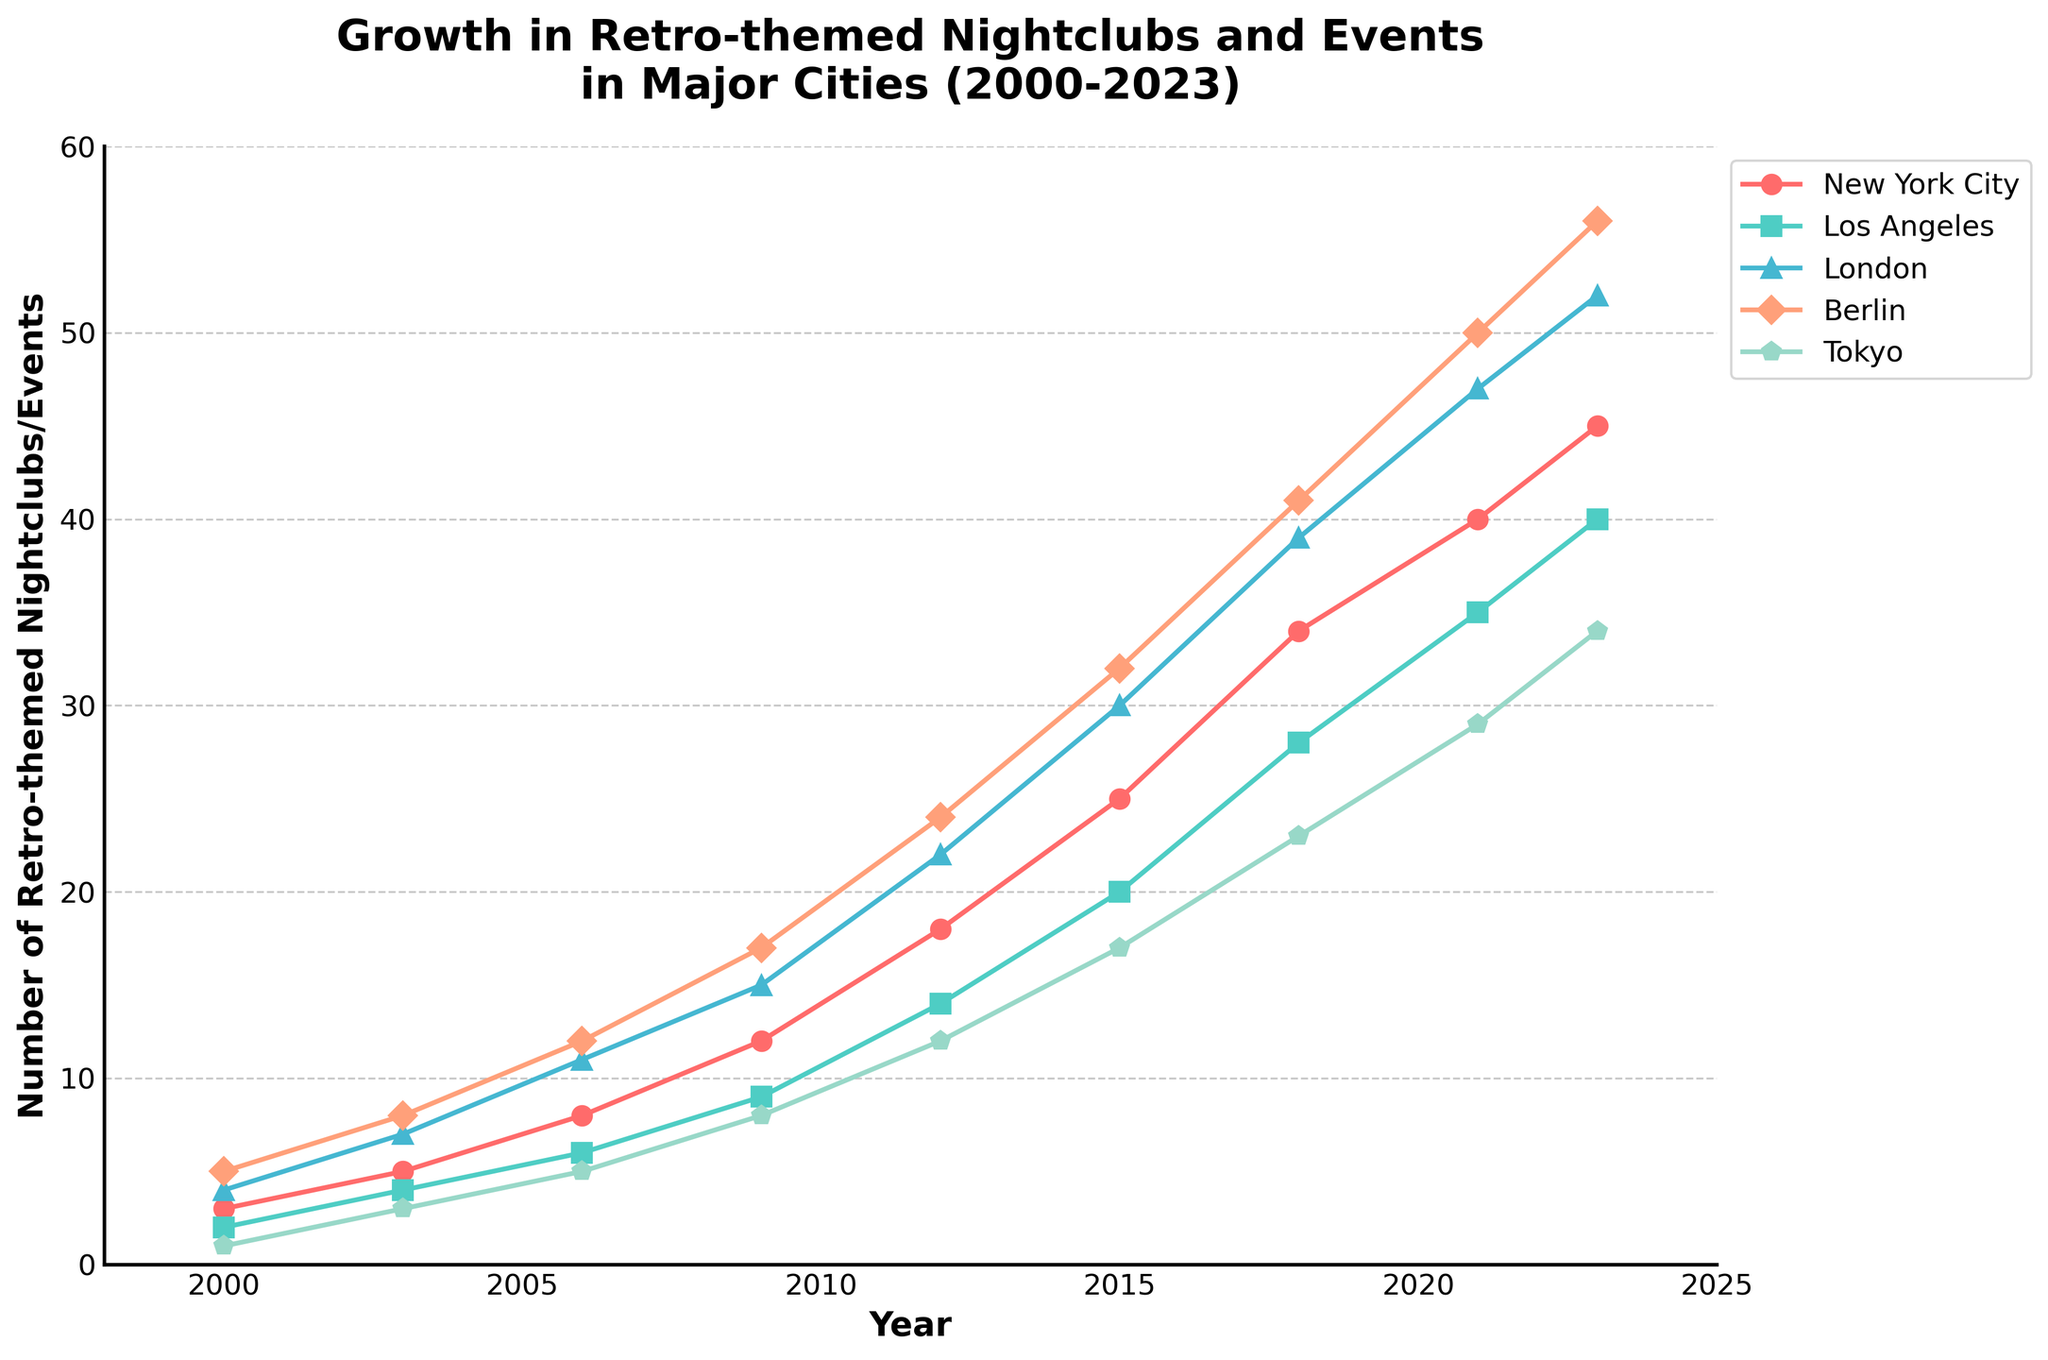What was the increase in the number of retro-themed nightclubs and events in Berlin from 2000 to 2023? The number of retro-themed nightclubs and events in Berlin in 2000 was 5, and it increased to 56 in 2023. The increase can be calculated by subtracting the number in 2000 from the number in 2023: 56 - 5.
Answer: 51 Which city had the highest number of retro-themed nightclubs and events in 2023? By checking the values for each city, we see that Berlin had 56, which is the highest compared to the other cities.
Answer: Berlin Which city experienced the least growth in retro-themed nightclubs and events from 2000 to 2023? Calculating the growth for each city: New York City (45-3=42), Los Angeles (40-2=38), London (52-4=48), Berlin (56-5=51), Tokyo (34-1=33). The least growth is for Tokyo with 33.
Answer: Tokyo What is the trend in the number of retro-themed nightclubs and events in New York City between 2000 and 2023? The number of retro-themed nightclubs and events in New York City increased steadily from 3 in 2000 to 45 in 2023, showing a positive upward trend.
Answer: Upward trend By how much did the number of retro-themed nightclubs and events in London surpass Los Angeles in 2023? The number for London in 2023 is 52, and for Los Angeles, it is 40. The difference is calculated by subtracting the number for Los Angeles from London: 52 - 40.
Answer: 12 Compare the number of retro-themed nightclubs and events in Tokyo and Los Angeles in 2012. Which city had more? The number for Tokyo in 2012 was 12, and for Los Angeles, it was 14. Therefore, Los Angeles had more.
Answer: Los Angeles What is the average number of retro-themed nightclubs and events in New York City in 2000, 2009, and 2023? Adding the numbers for these years in New York City: 3 (2000), 12 (2009), and 45 (2023), and dividing by 3: (3 + 12 + 45) / 3.
Answer: 20 Which city saw the highest increase in the number of retro-themed nightclubs and events between 2018 and 2021? New York City (40-34=6), Los Angeles (35-28=7), London (47-39=8), Berlin (50-41=9), Tokyo (29-23=6). Berlin saw the highest increase of 9.
Answer: Berlin 